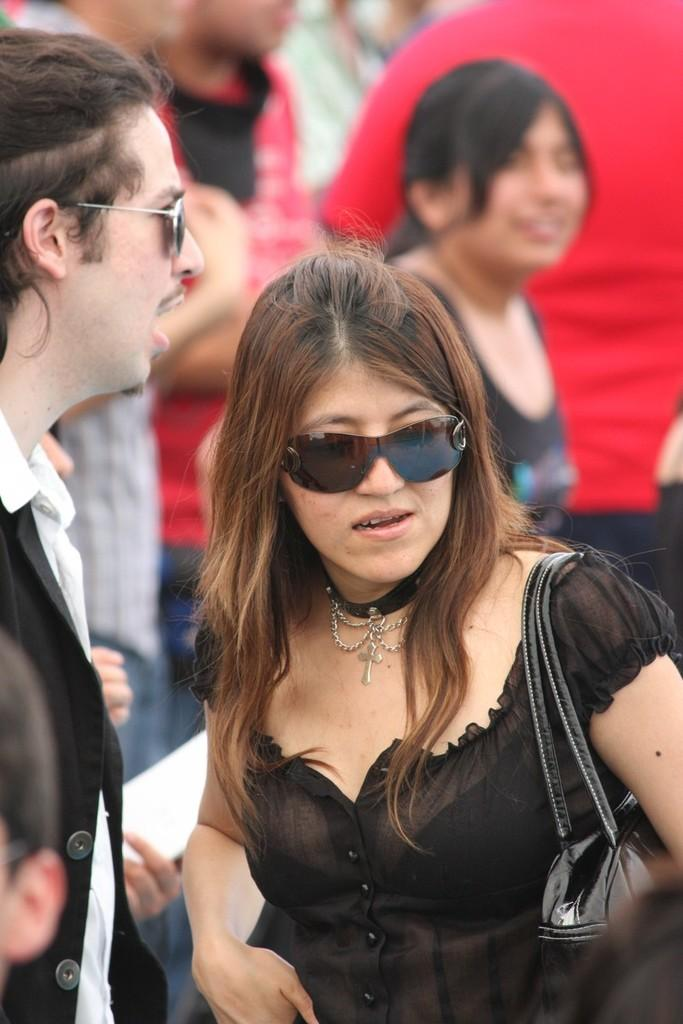Where was the image taken? The image is taken outdoors. Can you describe the people on the right side of the image? There is a woman on the right side of the image. What can be seen on the left side of the image? There is a man and a kid on the left side of the image. Are there any other people visible in the image? Yes, there are a few people in the background of the image. What type of eggs are being used to play a game of catch in the image? There are no eggs present in the image, and therefore no such activity can be observed. 